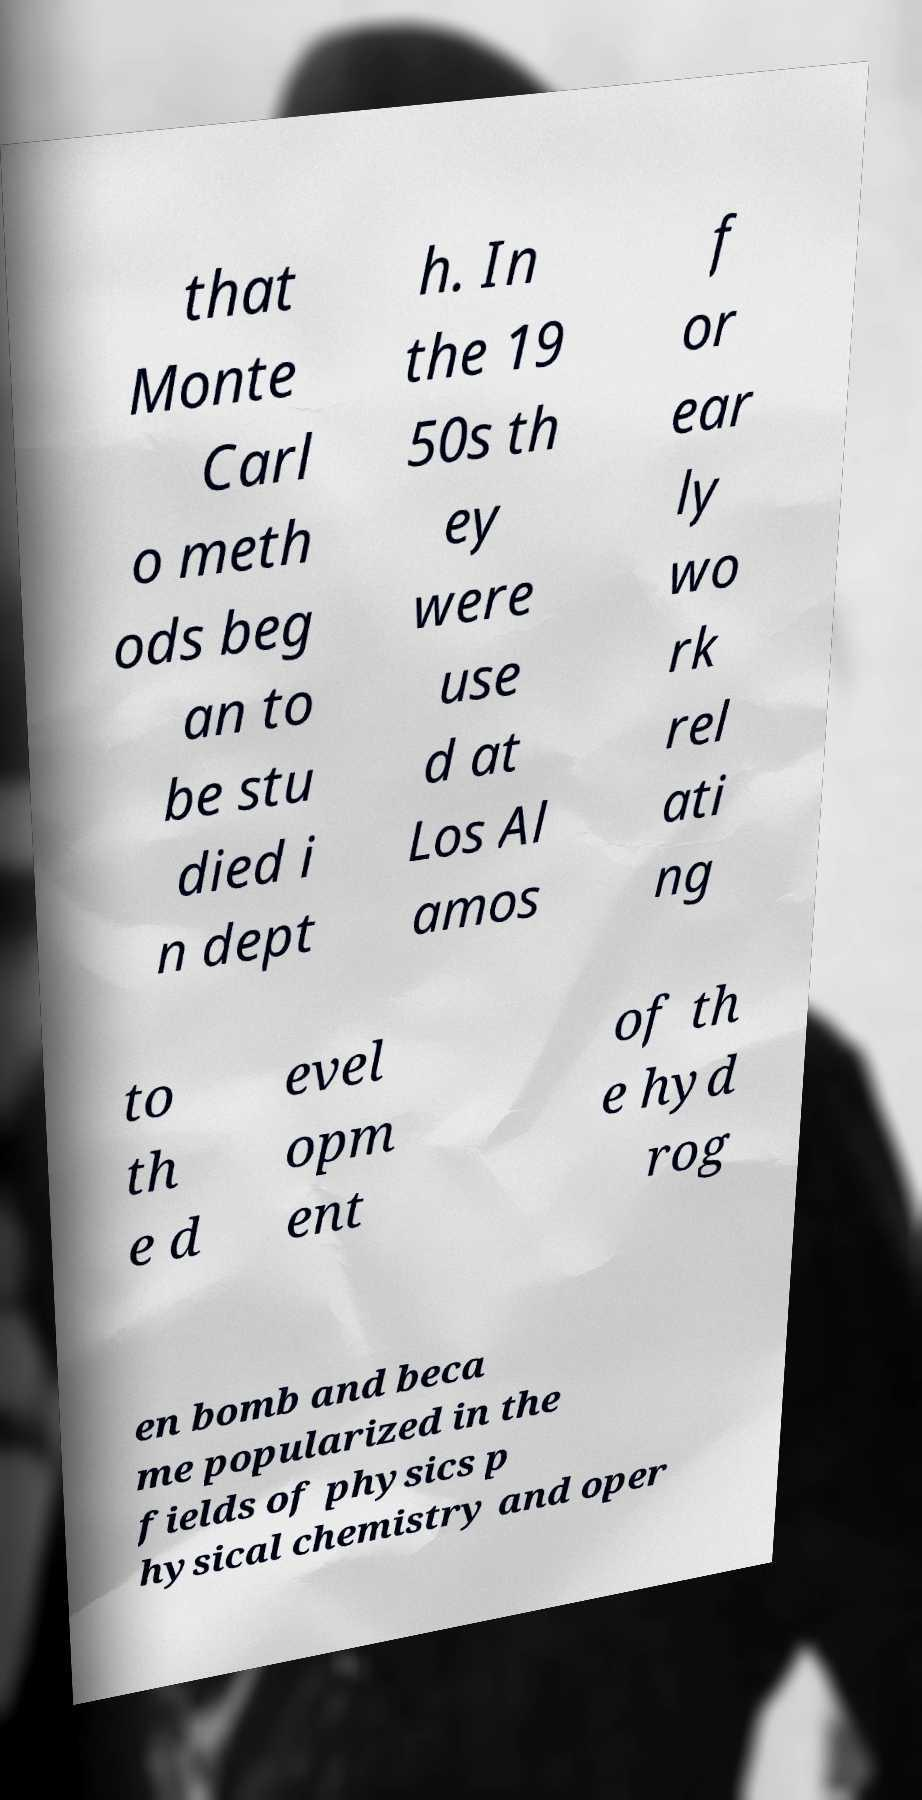There's text embedded in this image that I need extracted. Can you transcribe it verbatim? that Monte Carl o meth ods beg an to be stu died i n dept h. In the 19 50s th ey were use d at Los Al amos f or ear ly wo rk rel ati ng to th e d evel opm ent of th e hyd rog en bomb and beca me popularized in the fields of physics p hysical chemistry and oper 